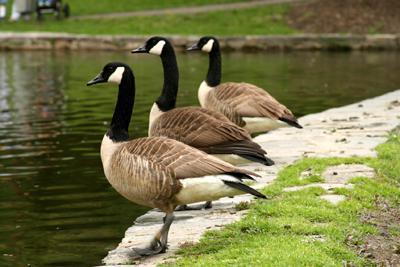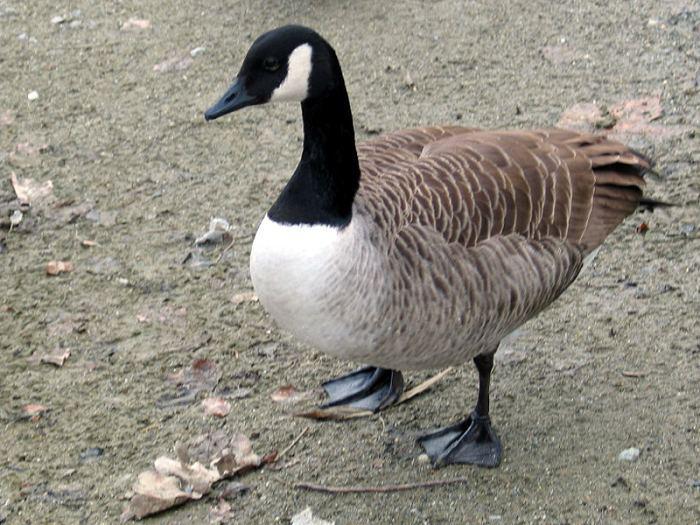The first image is the image on the left, the second image is the image on the right. Assess this claim about the two images: "There are exactly three ducks in the left image.". Correct or not? Answer yes or no. Yes. The first image is the image on the left, the second image is the image on the right. Analyze the images presented: Is the assertion "There are more birds in the image on the left than in the image on the right." valid? Answer yes or no. Yes. 